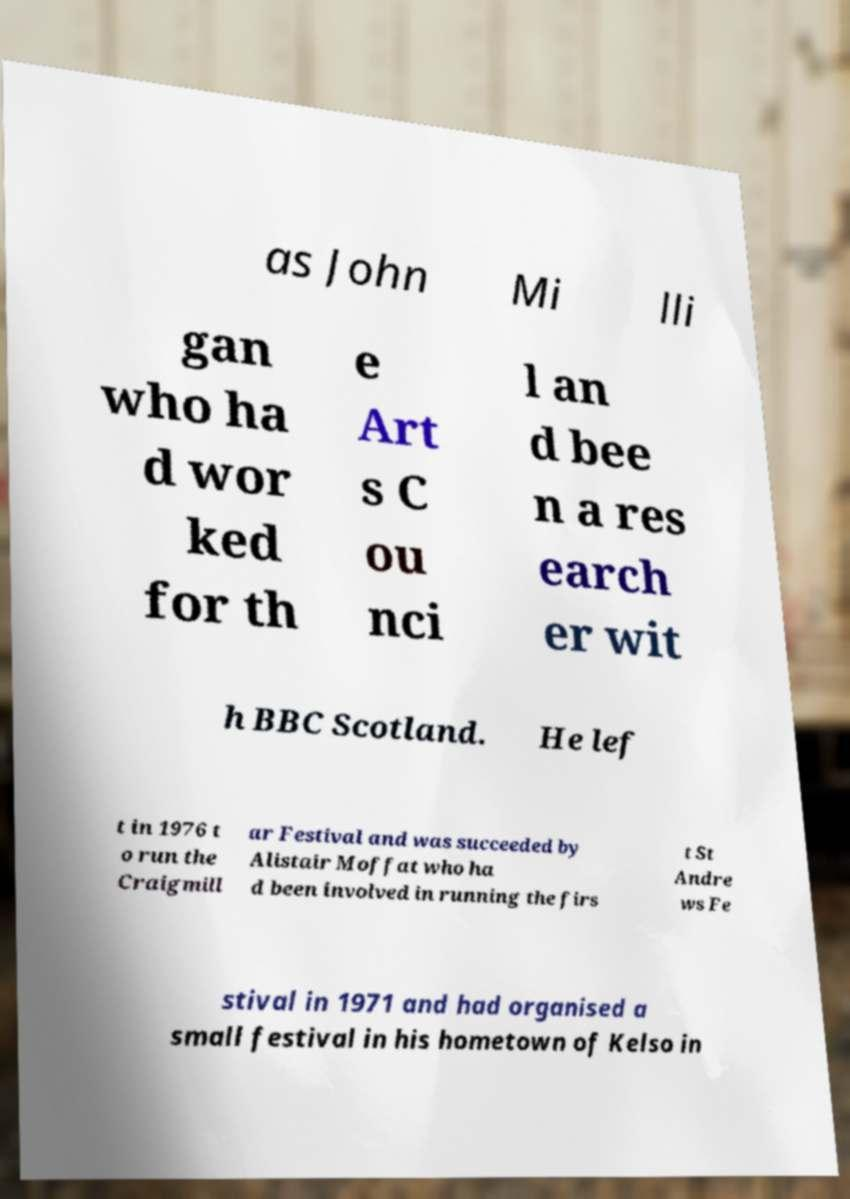Could you extract and type out the text from this image? as John Mi lli gan who ha d wor ked for th e Art s C ou nci l an d bee n a res earch er wit h BBC Scotland. He lef t in 1976 t o run the Craigmill ar Festival and was succeeded by Alistair Moffat who ha d been involved in running the firs t St Andre ws Fe stival in 1971 and had organised a small festival in his hometown of Kelso in 